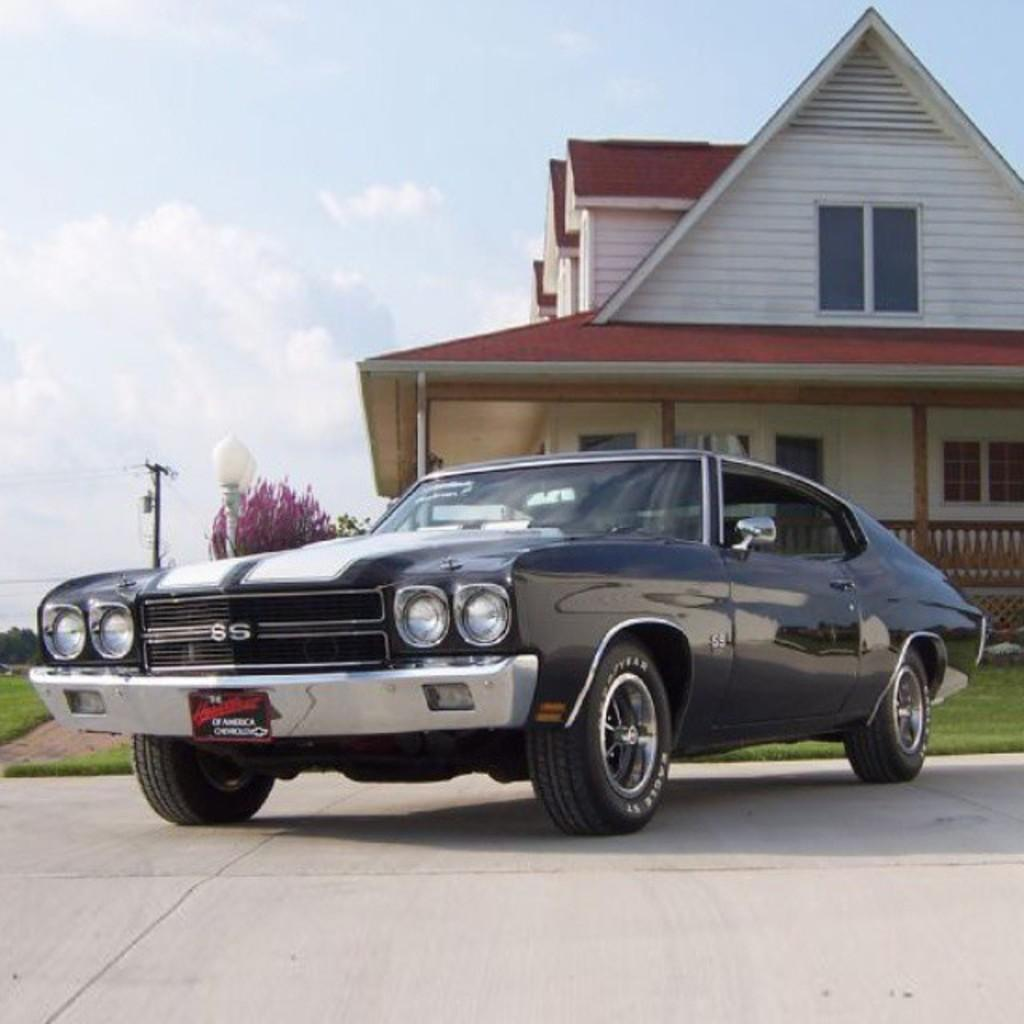What is the main subject of the image? The main subject of the image is a car. Can you describe the car's appearance? The car is black in color. Where is the car located in the image? The car is on the ground. What can be seen in the background of the image? There are trees, two poles, a building, and the sky visible in the background of the image. What type of liquid is dripping from the star in the image? There is no star or liquid present in the image. What is the car made of in the image? The car is made of metal, not wool. 